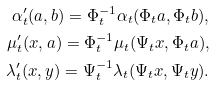<formula> <loc_0><loc_0><loc_500><loc_500>\alpha _ { t } ^ { \prime } ( a , b ) = \Phi _ { t } ^ { - 1 } \alpha _ { t } ( \Phi _ { t } a , \Phi _ { t } b ) , \\ \mu _ { t } ^ { \prime } ( x , a ) = \Phi _ { t } ^ { - 1 } \mu _ { t } ( \Psi _ { t } x , \Phi _ { t } a ) , \\ \lambda _ { t } ^ { \prime } ( x , y ) = \Psi _ { t } ^ { - 1 } \lambda _ { t } ( \Psi _ { t } x , \Psi _ { t } y ) .</formula> 